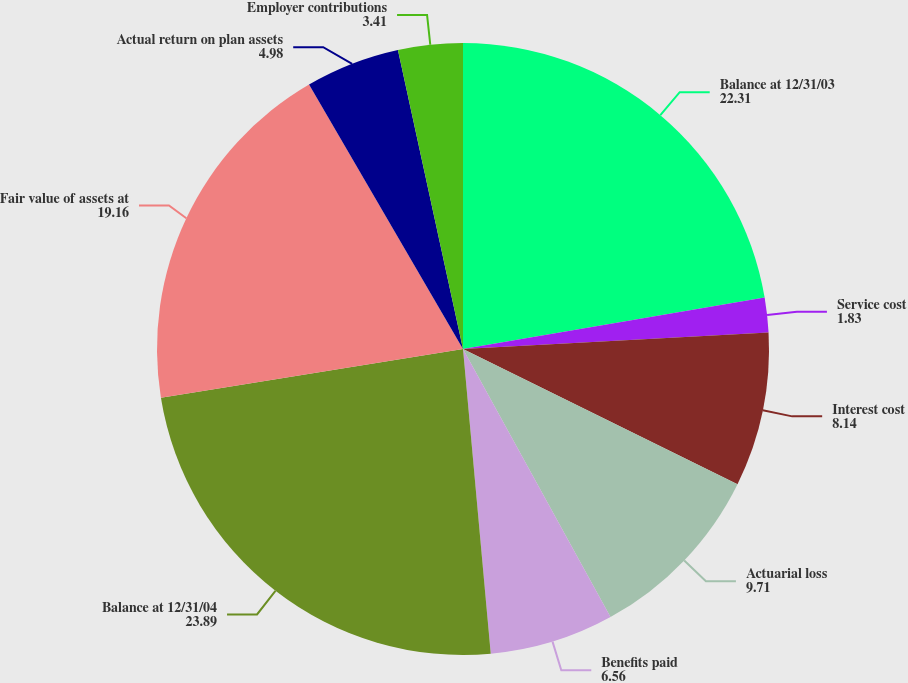Convert chart to OTSL. <chart><loc_0><loc_0><loc_500><loc_500><pie_chart><fcel>Balance at 12/31/03<fcel>Service cost<fcel>Interest cost<fcel>Actuarial loss<fcel>Benefits paid<fcel>Balance at 12/31/04<fcel>Fair value of assets at<fcel>Actual return on plan assets<fcel>Employer contributions<nl><fcel>22.31%<fcel>1.83%<fcel>8.14%<fcel>9.71%<fcel>6.56%<fcel>23.89%<fcel>19.16%<fcel>4.98%<fcel>3.41%<nl></chart> 